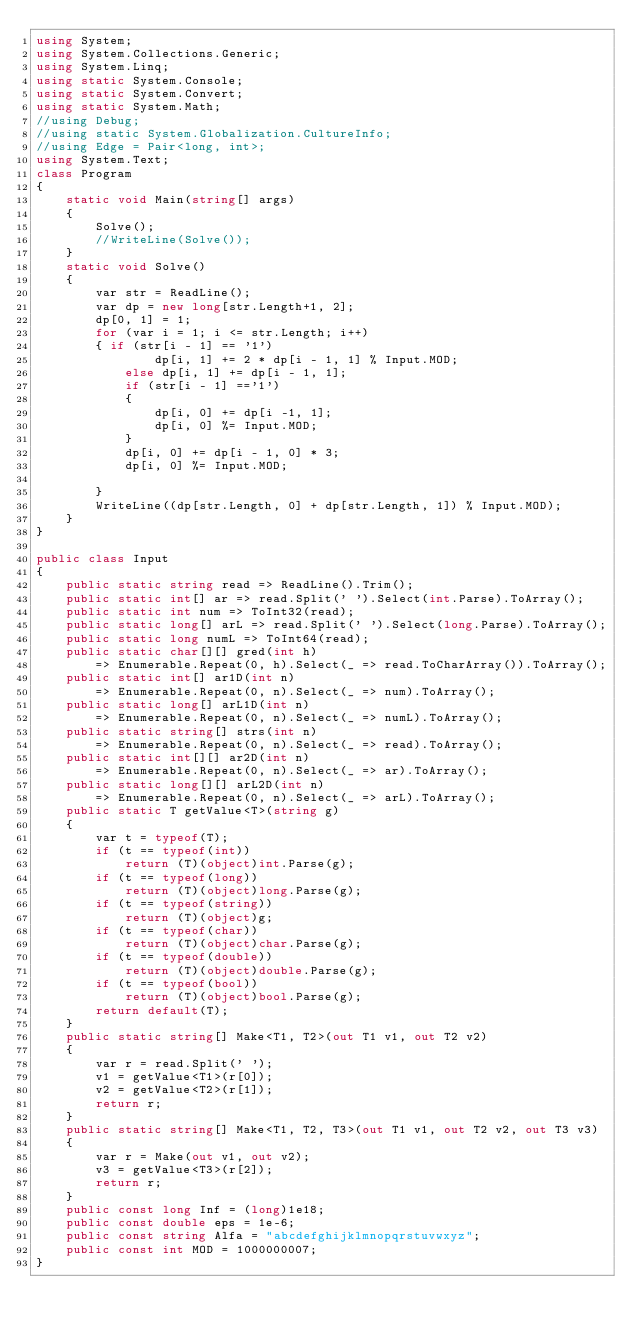Convert code to text. <code><loc_0><loc_0><loc_500><loc_500><_C#_>using System;
using System.Collections.Generic;
using System.Linq;
using static System.Console;
using static System.Convert;
using static System.Math;
//using Debug;
//using static System.Globalization.CultureInfo;
//using Edge = Pair<long, int>;
using System.Text;
class Program
{
    static void Main(string[] args)
    {
        Solve();
        //WriteLine(Solve());
    }
    static void Solve()
    {
        var str = ReadLine();
        var dp = new long[str.Length+1, 2];
        dp[0, 1] = 1;
        for (var i = 1; i <= str.Length; i++)
        { if (str[i - 1] == '1')
                dp[i, 1] += 2 * dp[i - 1, 1] % Input.MOD;
            else dp[i, 1] += dp[i - 1, 1];
            if (str[i - 1] =='1')
            {
                dp[i, 0] += dp[i -1, 1];
                dp[i, 0] %= Input.MOD;
            }
            dp[i, 0] += dp[i - 1, 0] * 3;
            dp[i, 0] %= Input.MOD;
           
        }
        WriteLine((dp[str.Length, 0] + dp[str.Length, 1]) % Input.MOD);
    }
}

public class Input
{
    public static string read => ReadLine().Trim();
    public static int[] ar => read.Split(' ').Select(int.Parse).ToArray();
    public static int num => ToInt32(read);
    public static long[] arL => read.Split(' ').Select(long.Parse).ToArray();
    public static long numL => ToInt64(read);
    public static char[][] gred(int h)
        => Enumerable.Repeat(0, h).Select(_ => read.ToCharArray()).ToArray();
    public static int[] ar1D(int n)
        => Enumerable.Repeat(0, n).Select(_ => num).ToArray();
    public static long[] arL1D(int n)
        => Enumerable.Repeat(0, n).Select(_ => numL).ToArray();
    public static string[] strs(int n)
        => Enumerable.Repeat(0, n).Select(_ => read).ToArray();
    public static int[][] ar2D(int n)
        => Enumerable.Repeat(0, n).Select(_ => ar).ToArray();
    public static long[][] arL2D(int n)
        => Enumerable.Repeat(0, n).Select(_ => arL).ToArray();
    public static T getValue<T>(string g)
    {
        var t = typeof(T);
        if (t == typeof(int))
            return (T)(object)int.Parse(g);
        if (t == typeof(long))
            return (T)(object)long.Parse(g);
        if (t == typeof(string))
            return (T)(object)g;
        if (t == typeof(char))
            return (T)(object)char.Parse(g);
        if (t == typeof(double))
            return (T)(object)double.Parse(g);
        if (t == typeof(bool))
            return (T)(object)bool.Parse(g);
        return default(T);
    }
    public static string[] Make<T1, T2>(out T1 v1, out T2 v2)
    {
        var r = read.Split(' ');
        v1 = getValue<T1>(r[0]);
        v2 = getValue<T2>(r[1]);
        return r;
    }
    public static string[] Make<T1, T2, T3>(out T1 v1, out T2 v2, out T3 v3)
    {
        var r = Make(out v1, out v2);
        v3 = getValue<T3>(r[2]);
        return r;
    }
    public const long Inf = (long)1e18;
    public const double eps = 1e-6;
    public const string Alfa = "abcdefghijklmnopqrstuvwxyz";
    public const int MOD = 1000000007;
}
</code> 